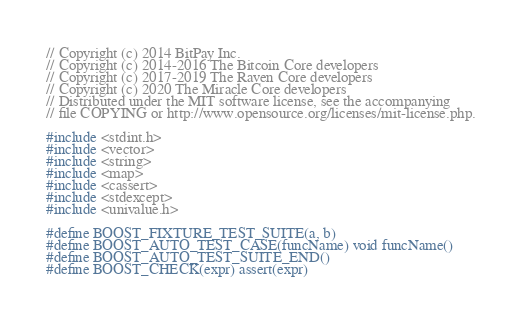Convert code to text. <code><loc_0><loc_0><loc_500><loc_500><_C++_>// Copyright (c) 2014 BitPay Inc.
// Copyright (c) 2014-2016 The Bitcoin Core developers
// Copyright (c) 2017-2019 The Raven Core developers
// Copyright (c) 2020 The Miracle Core developers
// Distributed under the MIT software license, see the accompanying
// file COPYING or http://www.opensource.org/licenses/mit-license.php.

#include <stdint.h>
#include <vector>
#include <string>
#include <map>
#include <cassert>
#include <stdexcept>
#include <univalue.h>

#define BOOST_FIXTURE_TEST_SUITE(a, b)
#define BOOST_AUTO_TEST_CASE(funcName) void funcName()
#define BOOST_AUTO_TEST_SUITE_END()
#define BOOST_CHECK(expr) assert(expr)</code> 